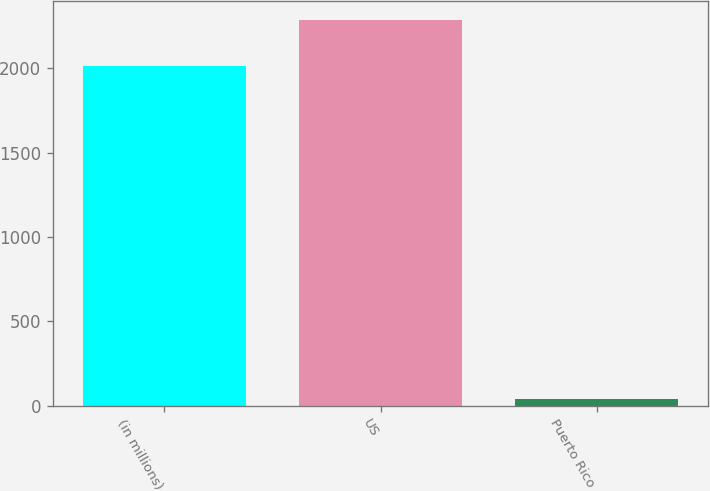Convert chart. <chart><loc_0><loc_0><loc_500><loc_500><bar_chart><fcel>(in millions)<fcel>US<fcel>Puerto Rico<nl><fcel>2016<fcel>2286<fcel>41<nl></chart> 